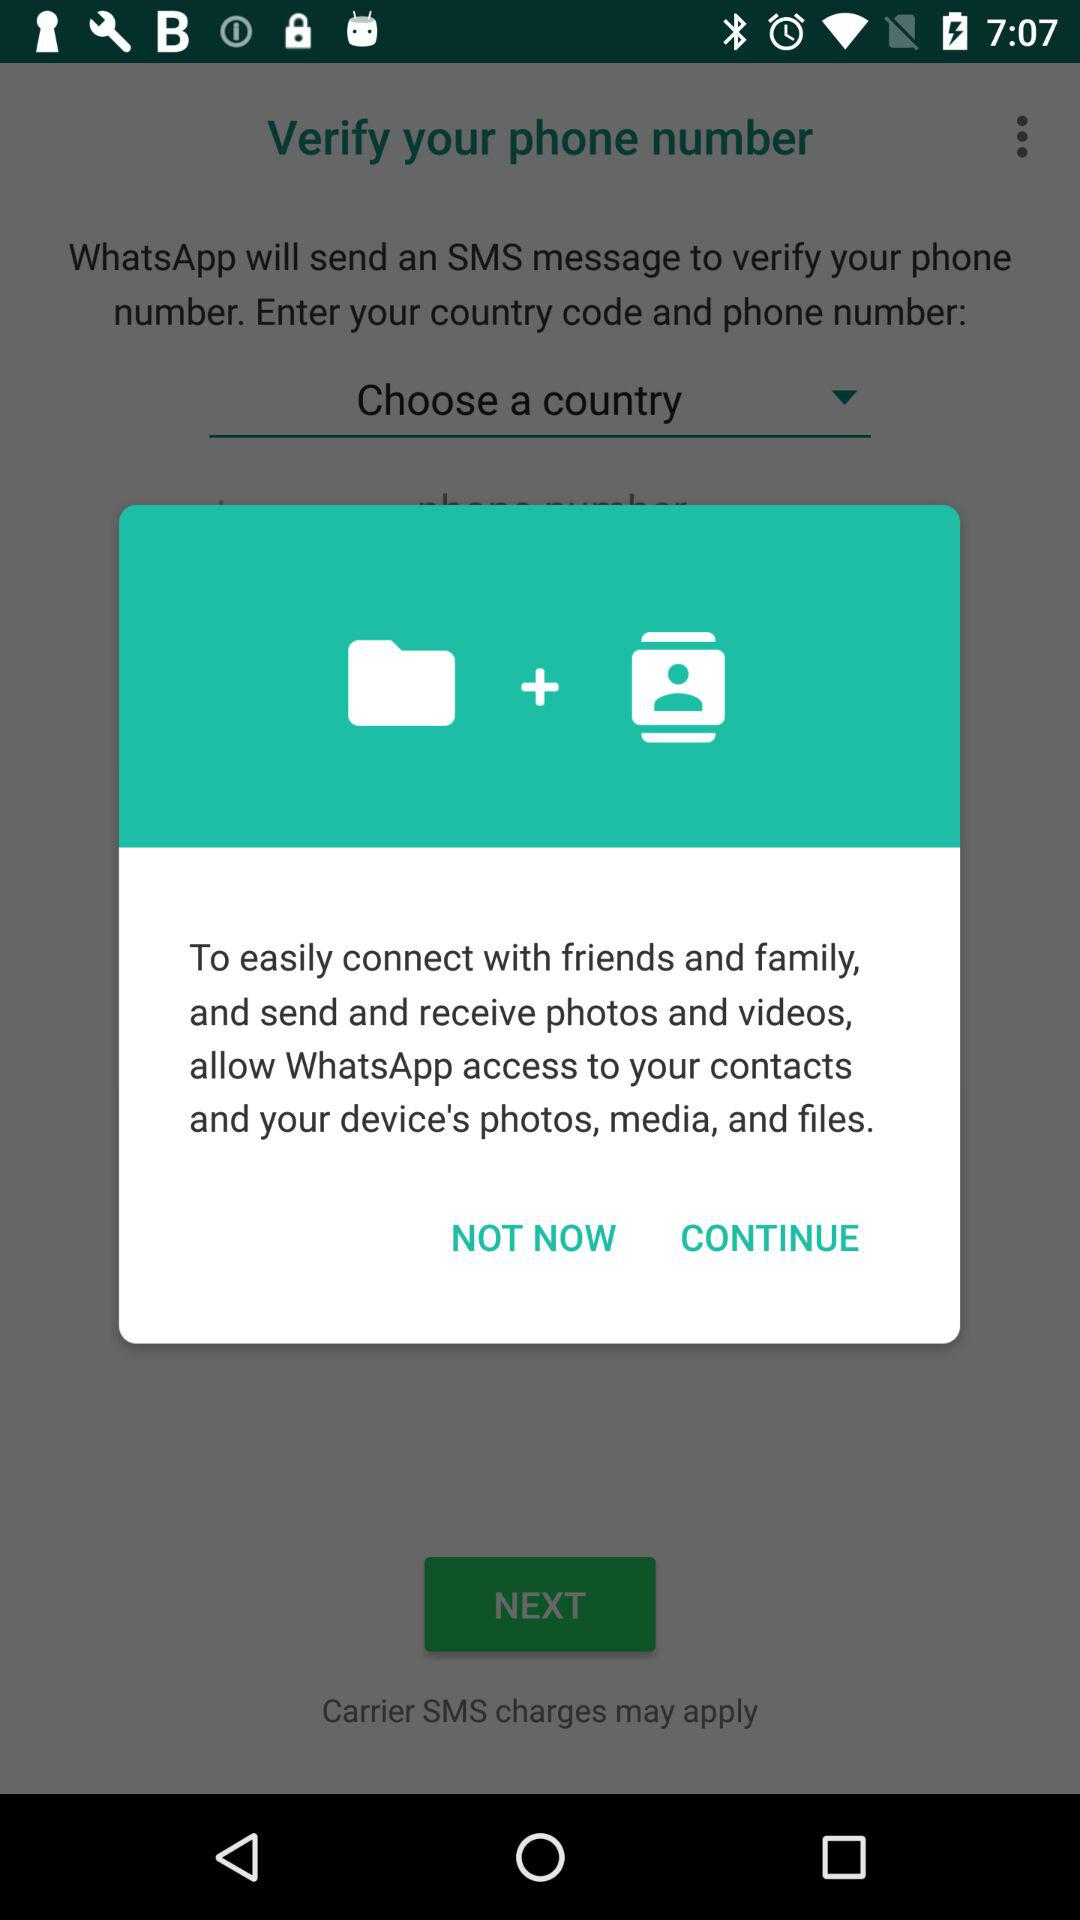What access does a user have to grant to easily connect with friends and family and send and receive photos and videos? A user has to grant access to his contacts, device's photos, media and files to easily connect with friends and family and send and receive photos and videos. 